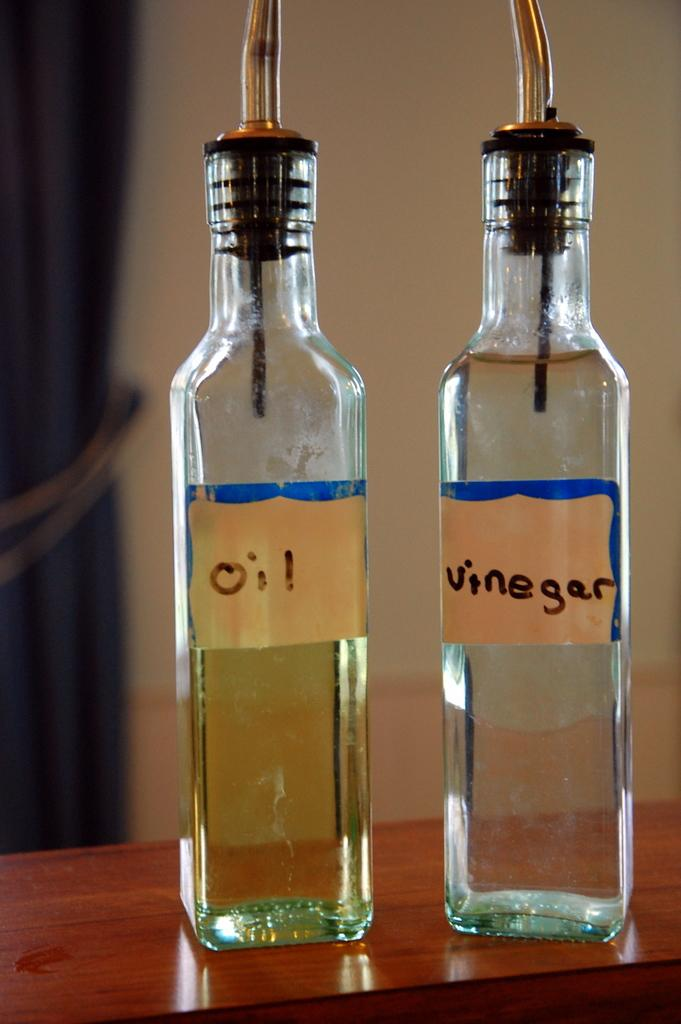<image>
Share a concise interpretation of the image provided. Two clear square glass bottles, one marked oil, the other vinegar. 